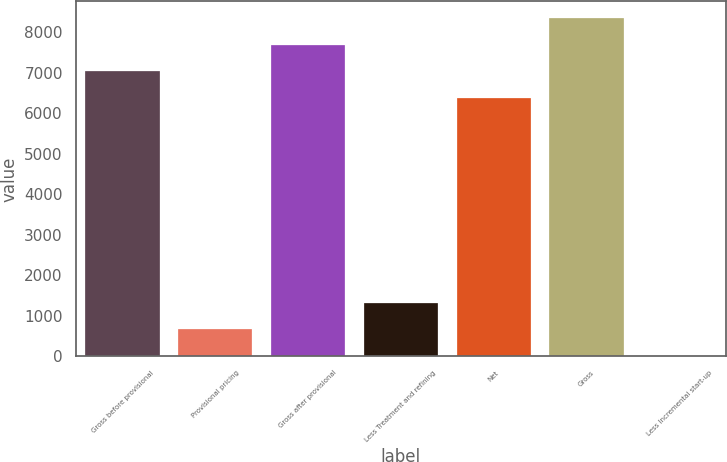Convert chart. <chart><loc_0><loc_0><loc_500><loc_500><bar_chart><fcel>Gross before provisional<fcel>Provisional pricing<fcel>Gross after provisional<fcel>Less Treatment and refining<fcel>Net<fcel>Gross<fcel>Less Incremental start-up<nl><fcel>7039.4<fcel>662.4<fcel>7692.8<fcel>1315.8<fcel>6386<fcel>8346.2<fcel>9<nl></chart> 